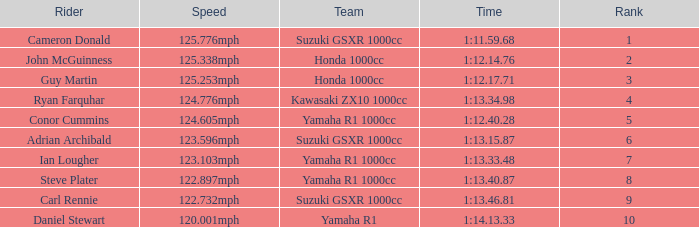What is the rank for the team with a Time of 1:12.40.28? 5.0. Can you give me this table as a dict? {'header': ['Rider', 'Speed', 'Team', 'Time', 'Rank'], 'rows': [['Cameron Donald', '125.776mph', 'Suzuki GSXR 1000cc', '1:11.59.68', '1'], ['John McGuinness', '125.338mph', 'Honda 1000cc', '1:12.14.76', '2'], ['Guy Martin', '125.253mph', 'Honda 1000cc', '1:12.17.71', '3'], ['Ryan Farquhar', '124.776mph', 'Kawasaki ZX10 1000cc', '1:13.34.98', '4'], ['Conor Cummins', '124.605mph', 'Yamaha R1 1000cc', '1:12.40.28', '5'], ['Adrian Archibald', '123.596mph', 'Suzuki GSXR 1000cc', '1:13.15.87', '6'], ['Ian Lougher', '123.103mph', 'Yamaha R1 1000cc', '1:13.33.48', '7'], ['Steve Plater', '122.897mph', 'Yamaha R1 1000cc', '1:13.40.87', '8'], ['Carl Rennie', '122.732mph', 'Suzuki GSXR 1000cc', '1:13.46.81', '9'], ['Daniel Stewart', '120.001mph', 'Yamaha R1', '1:14.13.33', '10']]} 